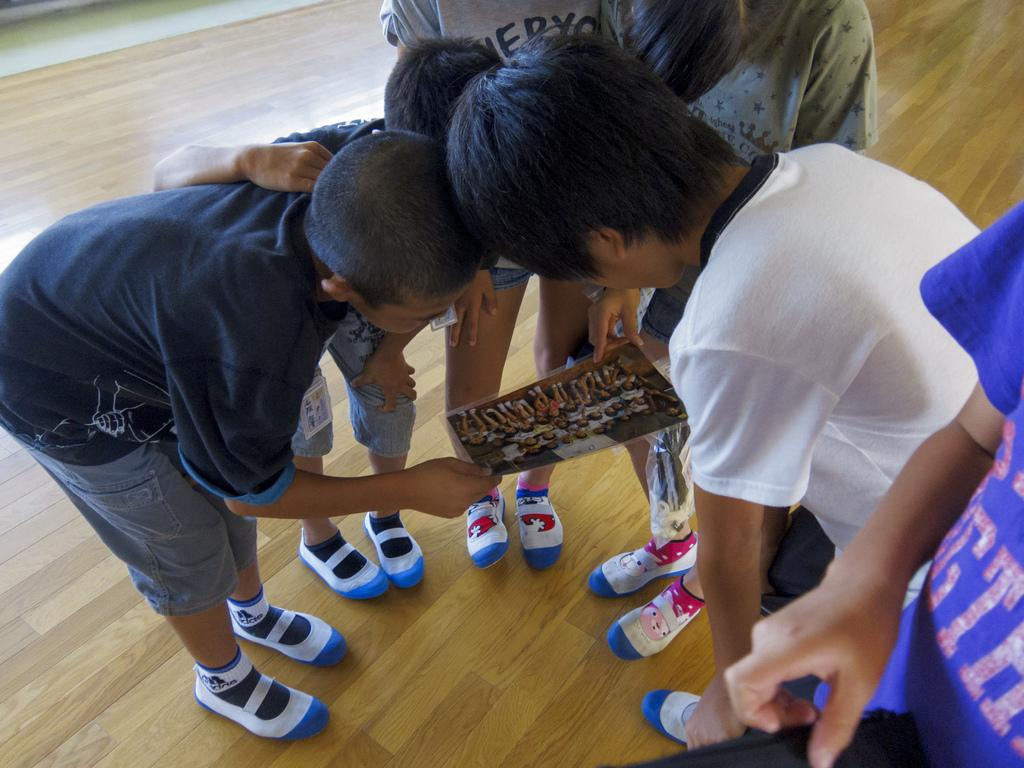What is the main subject of the image? The main subject of the image is a group of children. Where are the children located in the image? The children are standing in the center of the image. What are the children holding in the image? The children are holding a poster. What type of notebook is visible in the hands of the children in the image? There is no notebook present in the image; the children are holding a poster. 